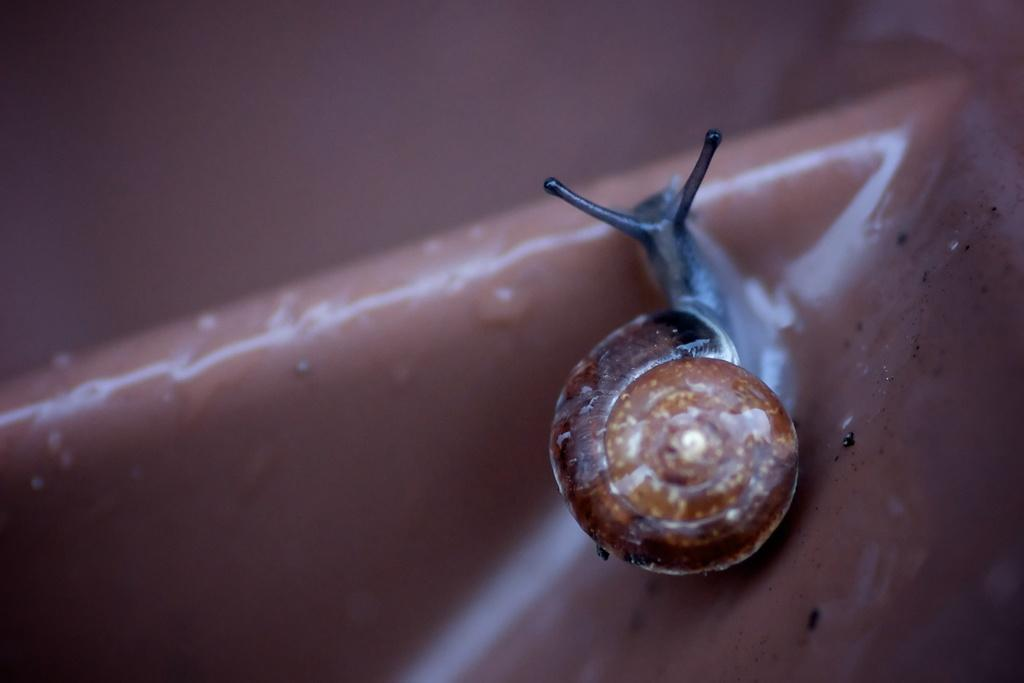What is the person in the image holding? The person is holding a camera. What is the person in the image doing with the camera? The person is taking a picture. What type of branch can be seen growing out of the person's ear in the image? There is no branch or ear present in the image; it features a person holding a camera and taking a picture. 